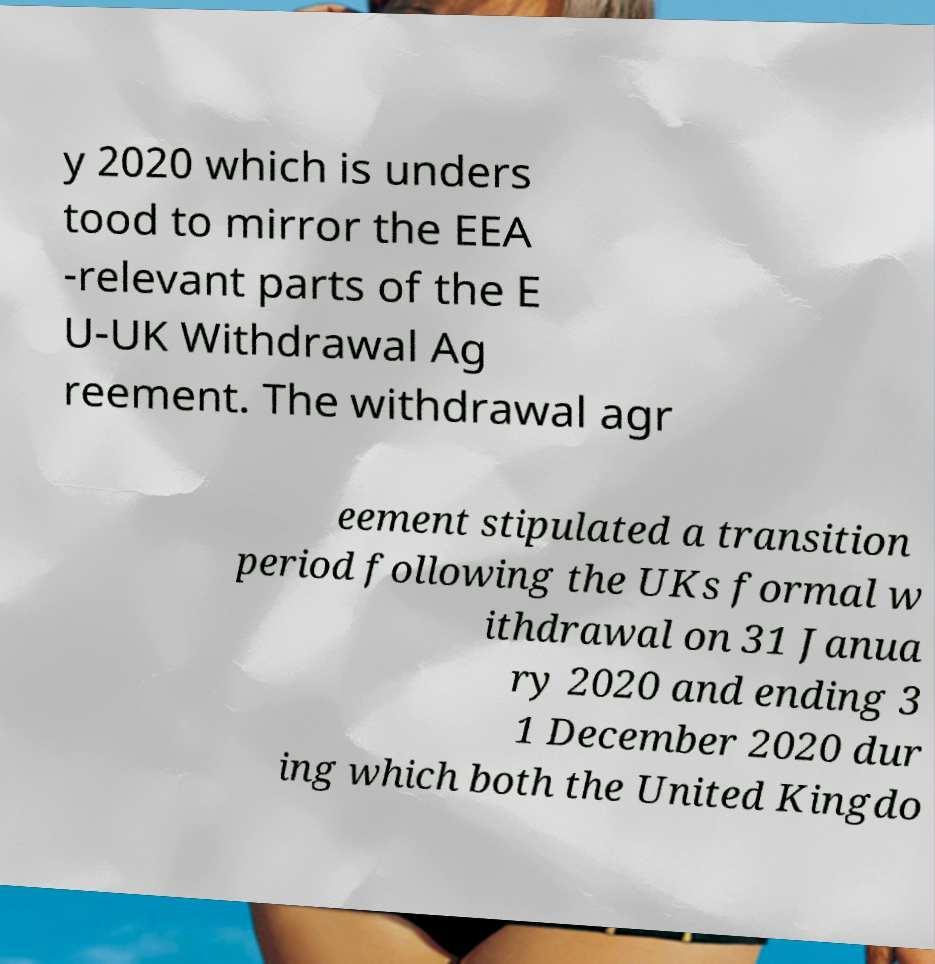There's text embedded in this image that I need extracted. Can you transcribe it verbatim? y 2020 which is unders tood to mirror the EEA -relevant parts of the E U-UK Withdrawal Ag reement. The withdrawal agr eement stipulated a transition period following the UKs formal w ithdrawal on 31 Janua ry 2020 and ending 3 1 December 2020 dur ing which both the United Kingdo 